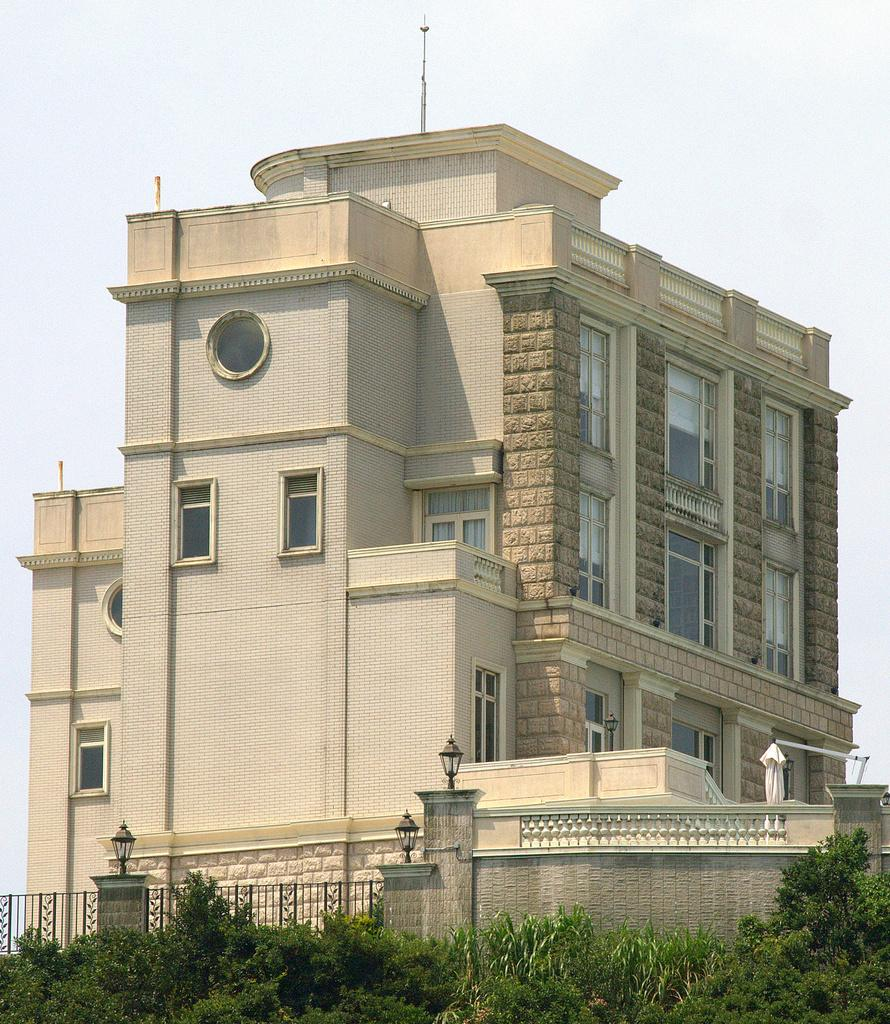What structure is the main subject of the image? There is a building in the image. What is in front of the building? There is a fence in front of the building. How is the fence connected to the wall? The fence is attached to a wall. What can be seen on the wall? There are lumps on the wall. What type of vegetation is present in the image? There are plants in front of the building. What is visible at the top of the image? The sky is visible at the top of the image. What type of jar is being used to celebrate the birthday party in the image? There is no jar or birthday party present in the image. What type of party decorations can be seen in the image? There are no party decorations present in the image. 